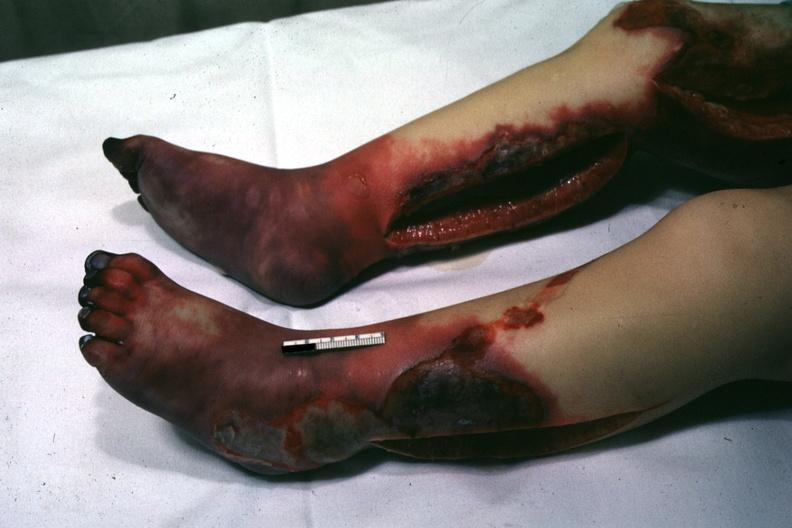what are present?
Answer the question using a single word or phrase. Extremities 